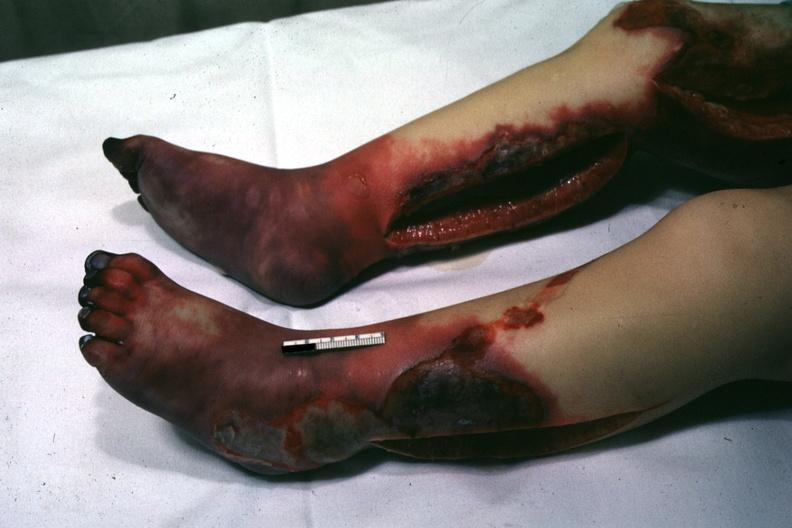what are present?
Answer the question using a single word or phrase. Extremities 